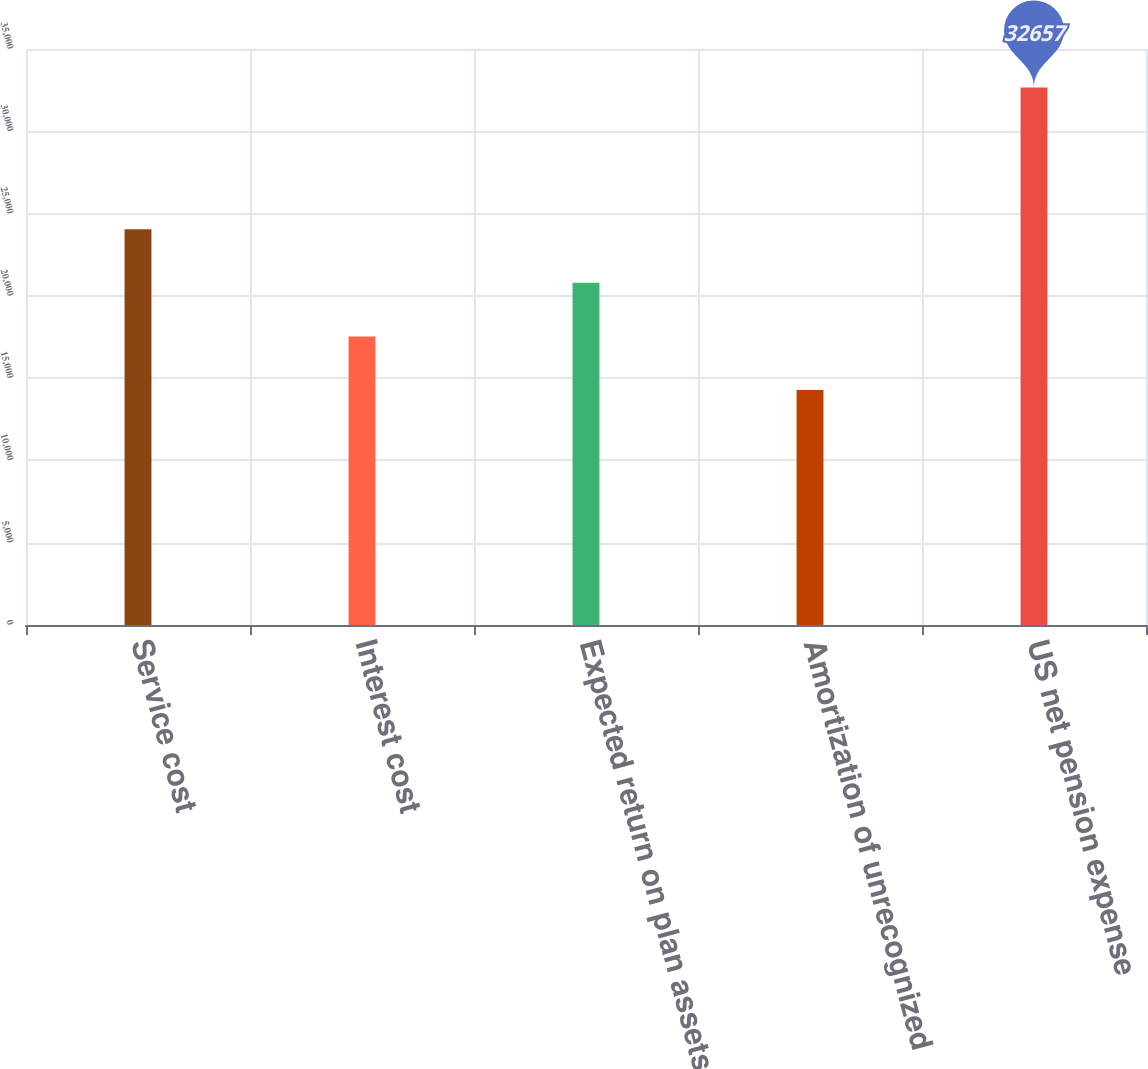Convert chart. <chart><loc_0><loc_0><loc_500><loc_500><bar_chart><fcel>Service cost<fcel>Interest cost<fcel>Expected return on plan assets<fcel>Amortization of unrecognized<fcel>US net pension expense<nl><fcel>24051<fcel>17537<fcel>20794<fcel>14280<fcel>32657<nl></chart> 